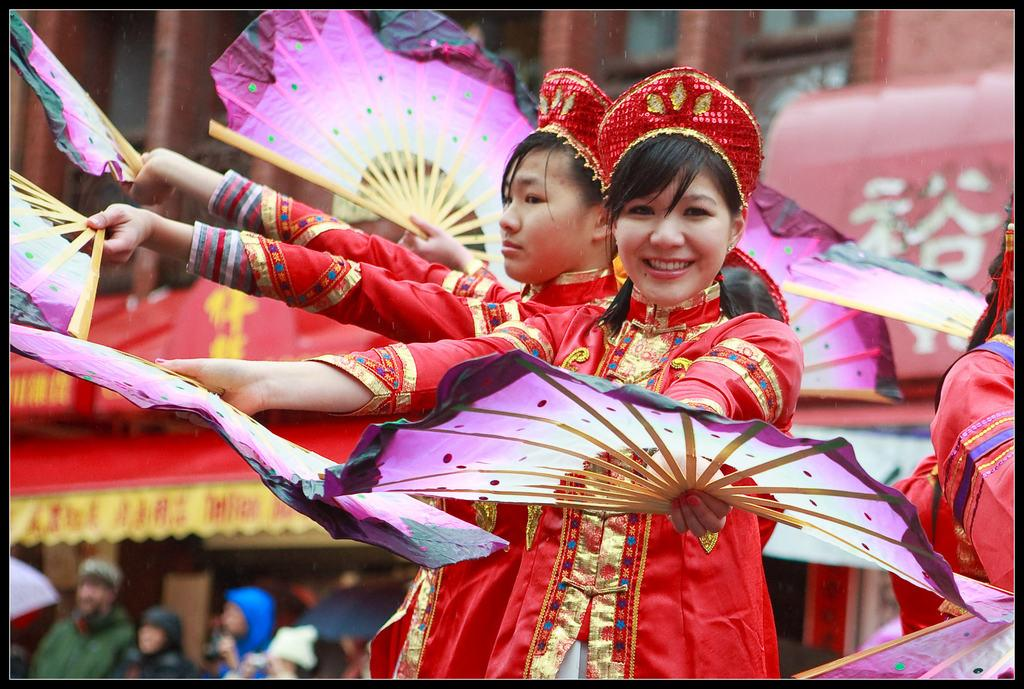Who is present in the image? There are people in the image. What are the people wearing? The people are wearing red color dresses. What are the people doing in the image? The people are dancing. What can be seen in the background of the image? There are buildings and a banner in the background of the image. How many companies are represented on the banner in the image? There is no information about companies on the banner in the image. 